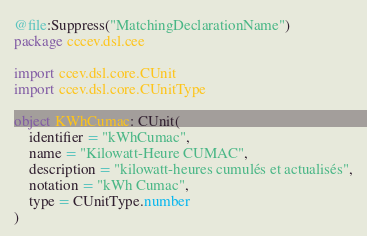Convert code to text. <code><loc_0><loc_0><loc_500><loc_500><_Kotlin_>@file:Suppress("MatchingDeclarationName")
package cccev.dsl.cee

import ccev.dsl.core.CUnit
import ccev.dsl.core.CUnitType

object KWhCumac: CUnit(
    identifier = "kWhCumac",
    name = "Kilowatt-Heure CUMAC",
    description = "kilowatt-heures cumulés et actualisés",
    notation = "kWh Cumac",
    type = CUnitType.number
)
</code> 